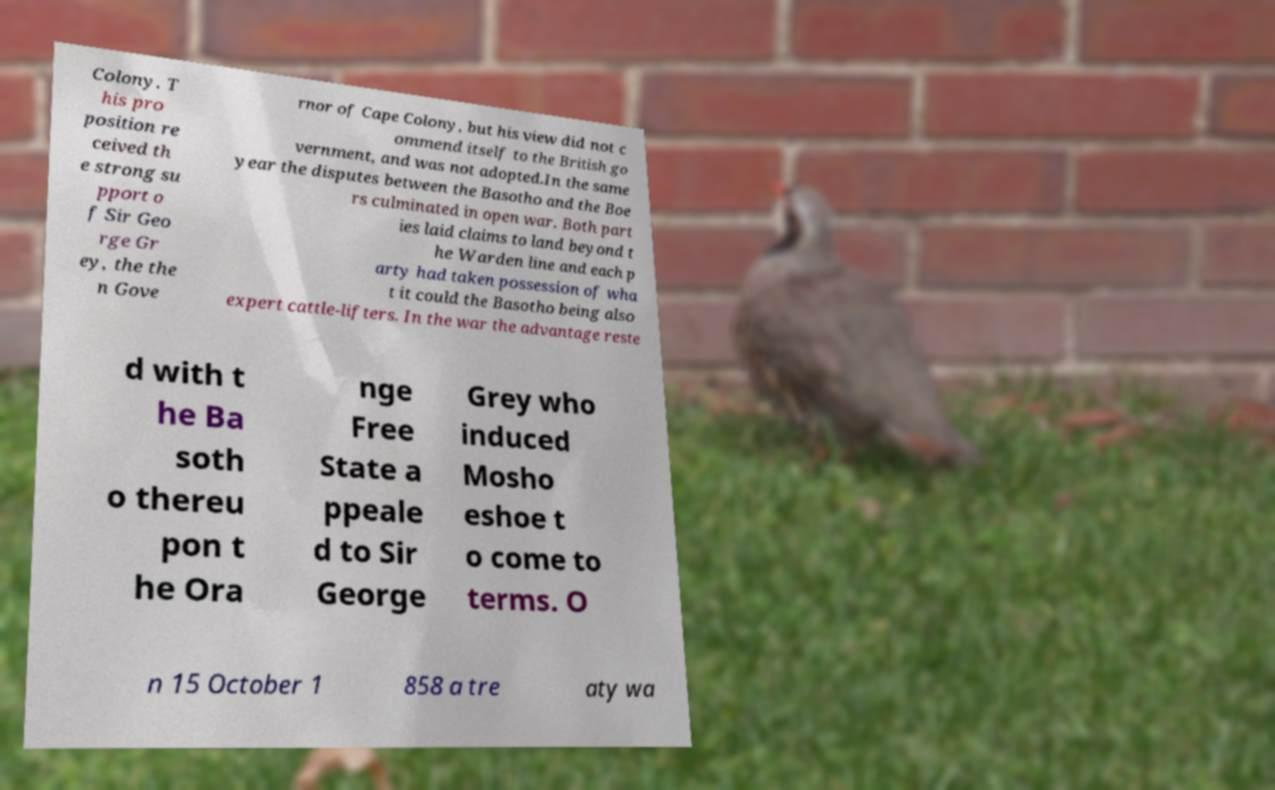Can you accurately transcribe the text from the provided image for me? Colony. T his pro position re ceived th e strong su pport o f Sir Geo rge Gr ey, the the n Gove rnor of Cape Colony, but his view did not c ommend itself to the British go vernment, and was not adopted.In the same year the disputes between the Basotho and the Boe rs culminated in open war. Both part ies laid claims to land beyond t he Warden line and each p arty had taken possession of wha t it could the Basotho being also expert cattle-lifters. In the war the advantage reste d with t he Ba soth o thereu pon t he Ora nge Free State a ppeale d to Sir George Grey who induced Mosho eshoe t o come to terms. O n 15 October 1 858 a tre aty wa 